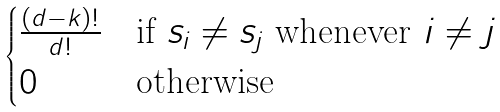<formula> <loc_0><loc_0><loc_500><loc_500>\begin{cases} \frac { ( d - k ) ! } { d ! } & \text {if } s _ { i } \neq s _ { j } \text { whenever } i \neq j \\ 0 & \text {otherwise} \end{cases}</formula> 